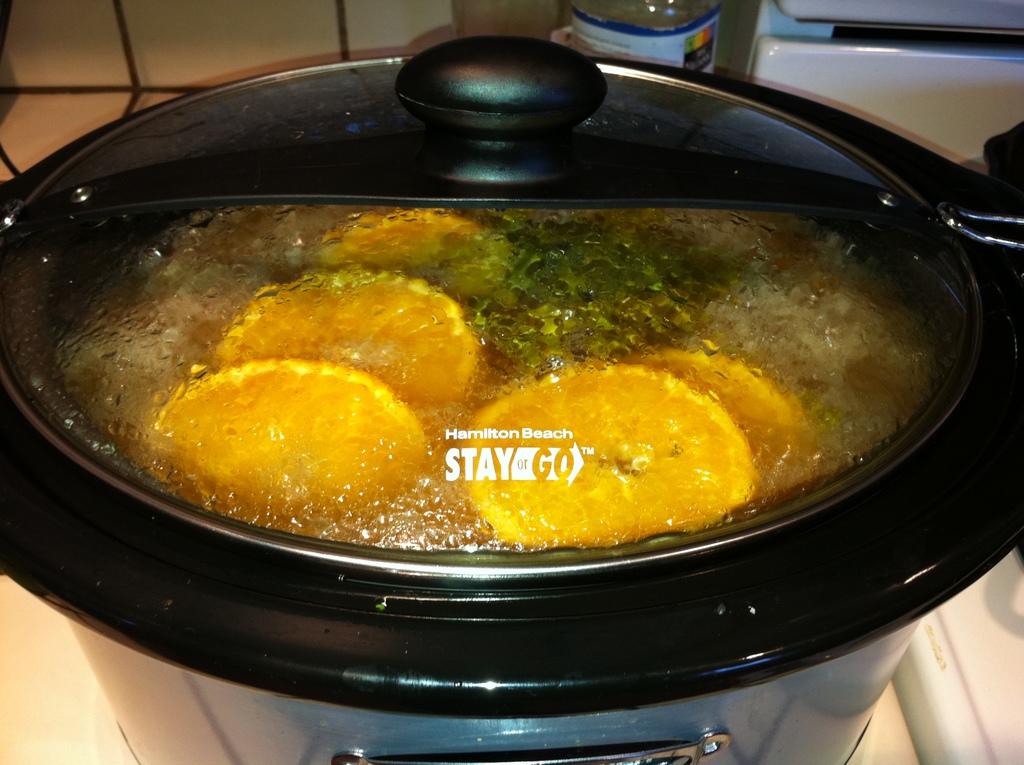What is the company name of this product?
Your answer should be compact. Hamilton beach. 